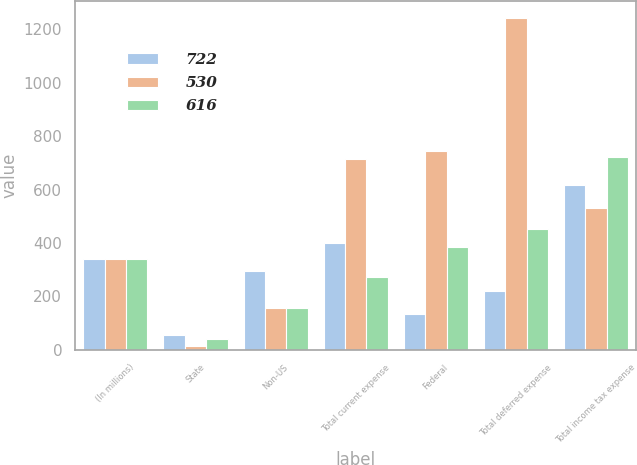<chart> <loc_0><loc_0><loc_500><loc_500><stacked_bar_chart><ecel><fcel>(In millions)<fcel>State<fcel>Non-US<fcel>Total current expense<fcel>Federal<fcel>Total deferred expense<fcel>Total income tax expense<nl><fcel>722<fcel>339<fcel>54<fcel>295<fcel>398<fcel>134<fcel>218<fcel>616<nl><fcel>530<fcel>339<fcel>15<fcel>156<fcel>714<fcel>745<fcel>1244<fcel>530<nl><fcel>616<fcel>339<fcel>39<fcel>157<fcel>271<fcel>383<fcel>451<fcel>722<nl></chart> 